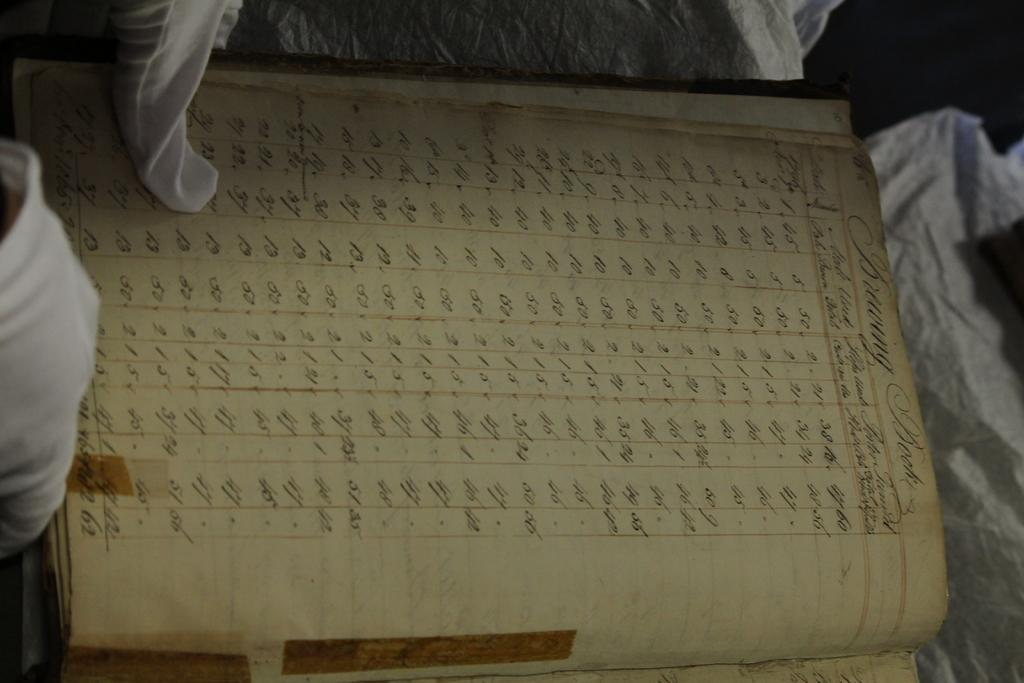What object can be seen in the image? There is a register in the image. What is on the register? Something is written in the register. Can you tell me how many baskets are on the register in the image? There is no mention of baskets in the image; the only object mentioned is the register, and something is written on it. Is there a woman holding a pet in the image? There is no information about a woman or a pet in the image; it only features a register with something written on it. 